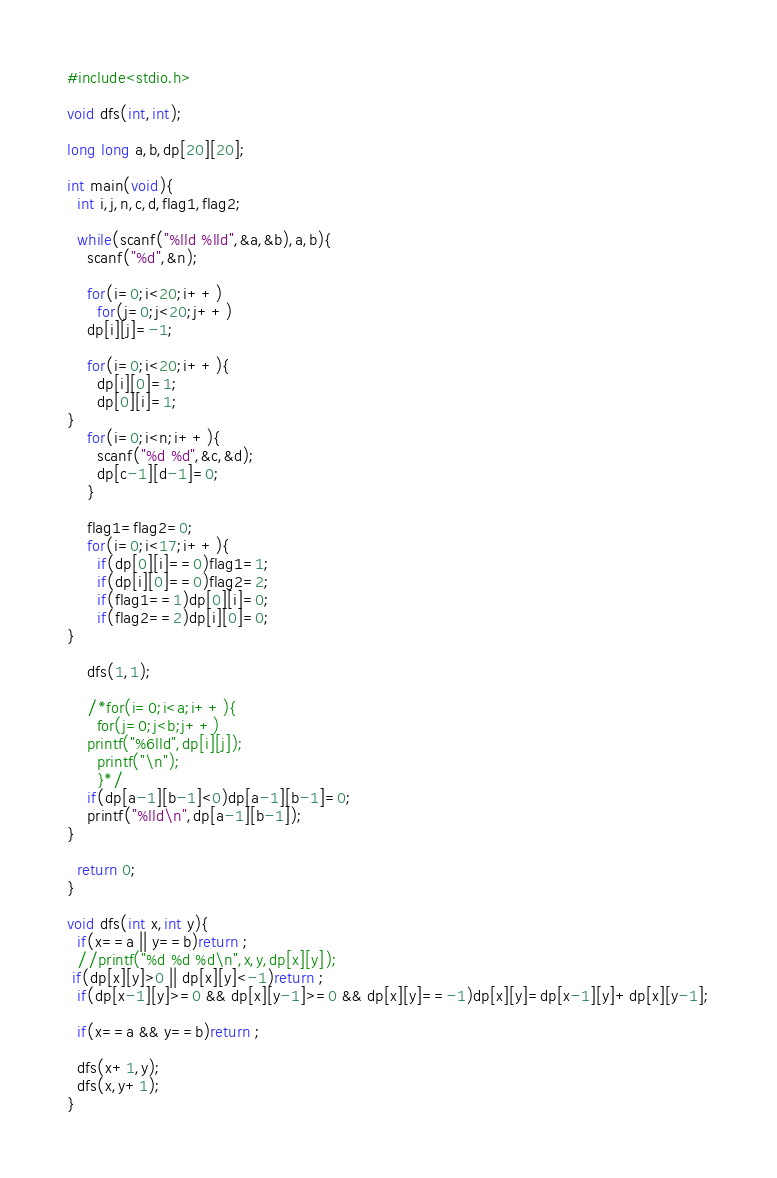Convert code to text. <code><loc_0><loc_0><loc_500><loc_500><_C_>#include<stdio.h>

void dfs(int,int);

long long a,b,dp[20][20];

int main(void){
  int i,j,n,c,d,flag1,flag2;

  while(scanf("%lld %lld",&a,&b),a,b){
    scanf("%d",&n);

    for(i=0;i<20;i++)
      for(j=0;j<20;j++)
	dp[i][j]=-1;

    for(i=0;i<20;i++){
      dp[i][0]=1;
      dp[0][i]=1;
}
    for(i=0;i<n;i++){
      scanf("%d %d",&c,&d);
      dp[c-1][d-1]=0;
    }

    flag1=flag2=0;
    for(i=0;i<17;i++){
      if(dp[0][i]==0)flag1=1;
      if(dp[i][0]==0)flag2=2;
      if(flag1==1)dp[0][i]=0;
      if(flag2==2)dp[i][0]=0;
}

    dfs(1,1);

    /*for(i=0;i<a;i++){
      for(j=0;j<b;j++)
	printf("%6lld",dp[i][j]);
      printf("\n");
      }*/
    if(dp[a-1][b-1]<0)dp[a-1][b-1]=0;
    printf("%lld\n",dp[a-1][b-1]);
}

  return 0;
}

void dfs(int x,int y){
  if(x==a || y==b)return ;
  //printf("%d %d %d\n",x,y,dp[x][y]);
 if(dp[x][y]>0 || dp[x][y]<-1)return ;
  if(dp[x-1][y]>=0 && dp[x][y-1]>=0 && dp[x][y]==-1)dp[x][y]=dp[x-1][y]+dp[x][y-1];

  if(x==a && y==b)return ;

  dfs(x+1,y);
  dfs(x,y+1);
}</code> 